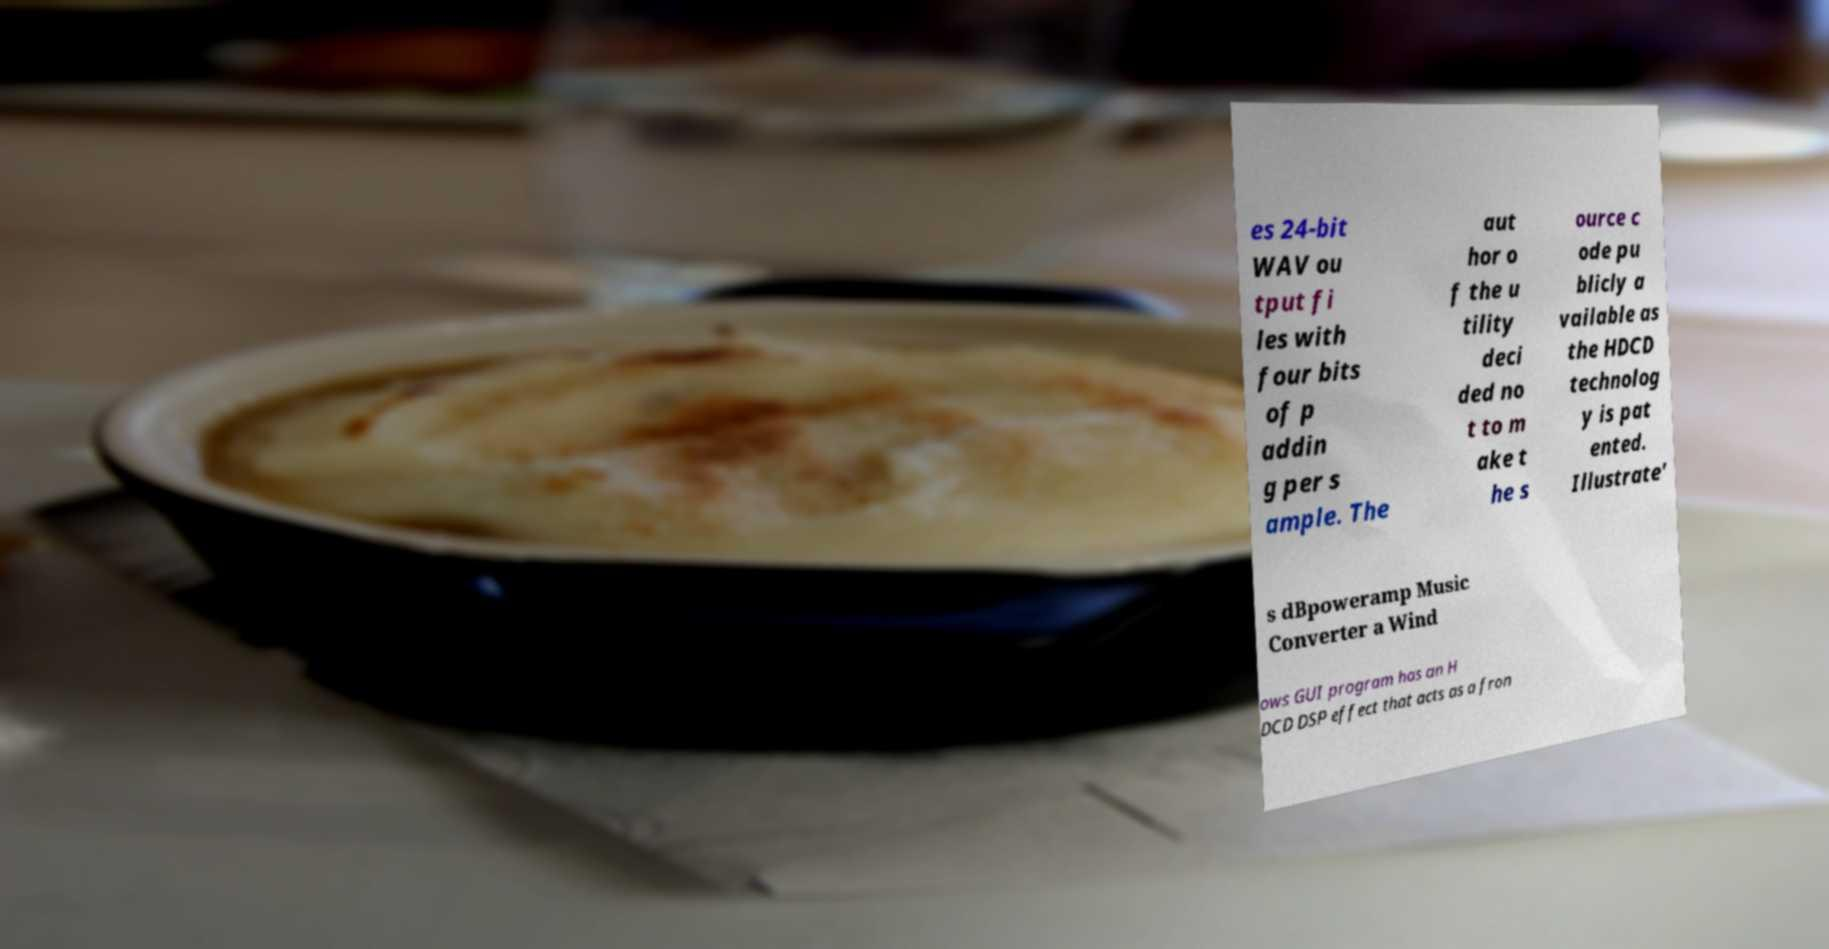Please read and relay the text visible in this image. What does it say? es 24-bit WAV ou tput fi les with four bits of p addin g per s ample. The aut hor o f the u tility deci ded no t to m ake t he s ource c ode pu blicly a vailable as the HDCD technolog y is pat ented. Illustrate' s dBpoweramp Music Converter a Wind ows GUI program has an H DCD DSP effect that acts as a fron 